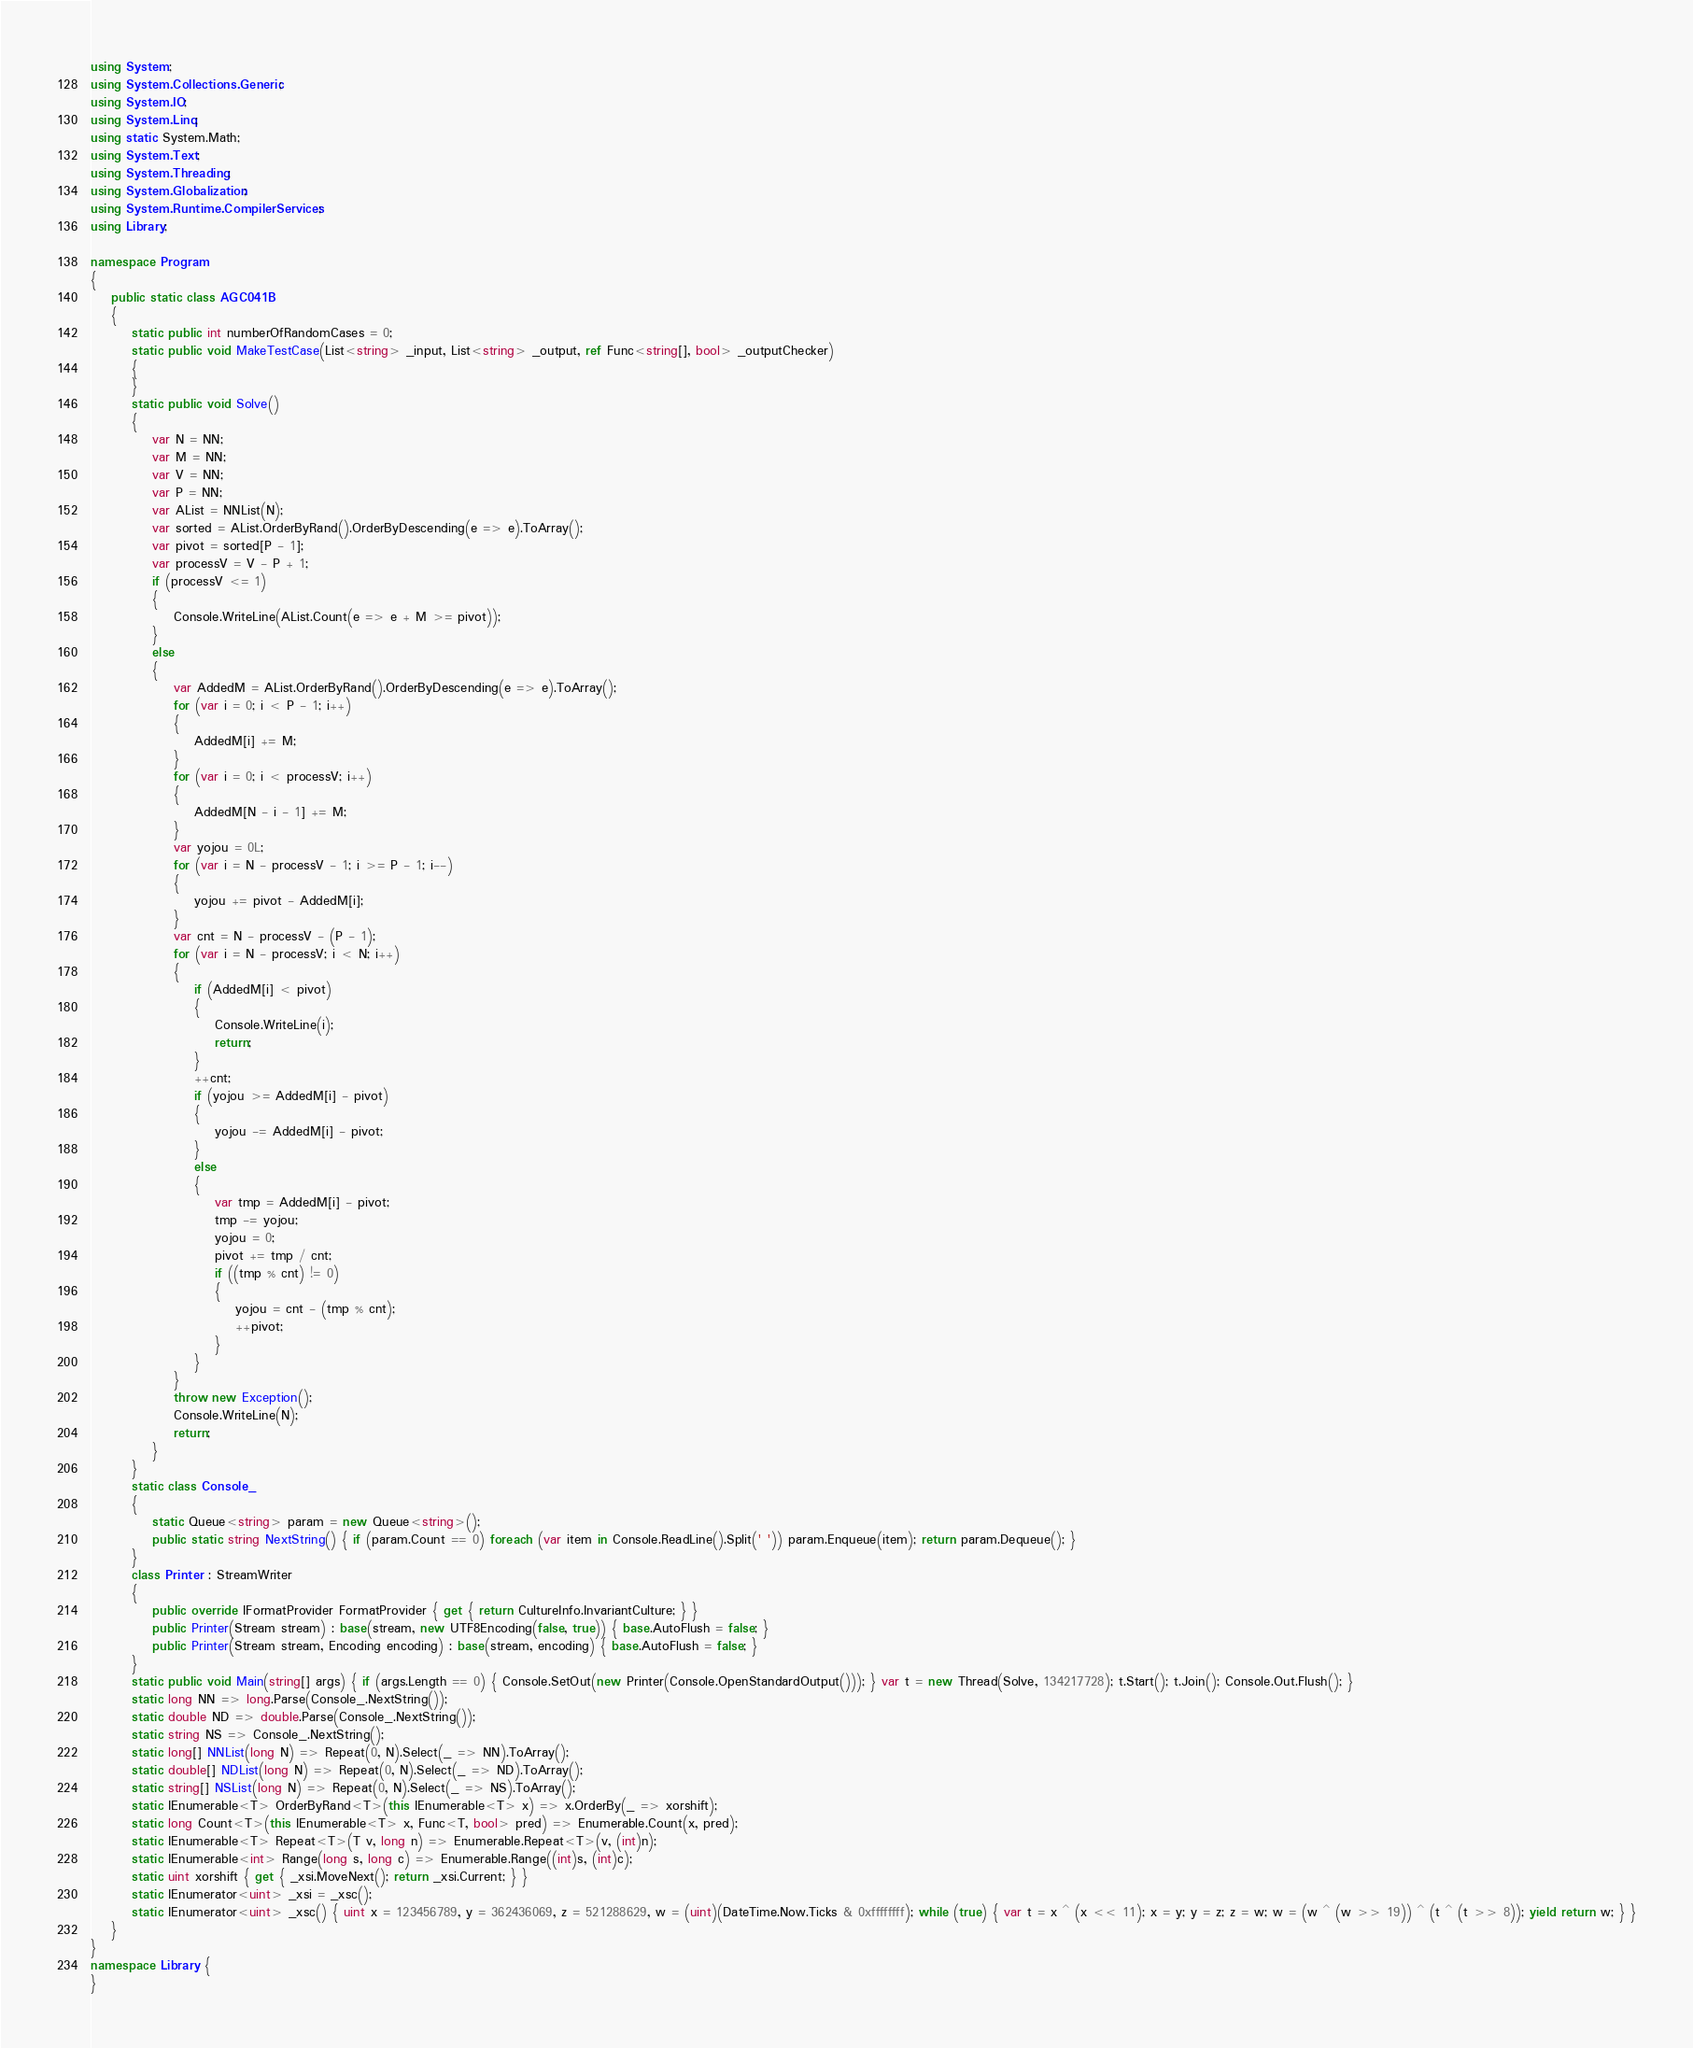<code> <loc_0><loc_0><loc_500><loc_500><_C#_>using System;
using System.Collections.Generic;
using System.IO;
using System.Linq;
using static System.Math;
using System.Text;
using System.Threading;
using System.Globalization;
using System.Runtime.CompilerServices;
using Library;

namespace Program
{
    public static class AGC041B
    {
        static public int numberOfRandomCases = 0;
        static public void MakeTestCase(List<string> _input, List<string> _output, ref Func<string[], bool> _outputChecker)
        {
        }
        static public void Solve()
        {
            var N = NN;
            var M = NN;
            var V = NN;
            var P = NN;
            var AList = NNList(N);
            var sorted = AList.OrderByRand().OrderByDescending(e => e).ToArray();
            var pivot = sorted[P - 1];
            var processV = V - P + 1;
            if (processV <= 1)
            {
                Console.WriteLine(AList.Count(e => e + M >= pivot));
            }
            else
            {
                var AddedM = AList.OrderByRand().OrderByDescending(e => e).ToArray();
                for (var i = 0; i < P - 1; i++)
                {
                    AddedM[i] += M;
                }
                for (var i = 0; i < processV; i++)
                {
                    AddedM[N - i - 1] += M;
                }
                var yojou = 0L;
                for (var i = N - processV - 1; i >= P - 1; i--)
                {
                    yojou += pivot - AddedM[i];
                }
                var cnt = N - processV - (P - 1);
                for (var i = N - processV; i < N; i++)
                {
                    if (AddedM[i] < pivot)
                    {
                        Console.WriteLine(i);
                        return;
                    }
                    ++cnt;
                    if (yojou >= AddedM[i] - pivot)
                    {
                        yojou -= AddedM[i] - pivot;
                    }
                    else
                    {
                        var tmp = AddedM[i] - pivot;
                        tmp -= yojou;
                        yojou = 0;
                        pivot += tmp / cnt;
                        if ((tmp % cnt) != 0)
                        {
                            yojou = cnt - (tmp % cnt);
                            ++pivot;
                        }
                    }
                }
                throw new Exception();
                Console.WriteLine(N);
                return;
            }
        }
        static class Console_
        {
            static Queue<string> param = new Queue<string>();
            public static string NextString() { if (param.Count == 0) foreach (var item in Console.ReadLine().Split(' ')) param.Enqueue(item); return param.Dequeue(); }
        }
        class Printer : StreamWriter
        {
            public override IFormatProvider FormatProvider { get { return CultureInfo.InvariantCulture; } }
            public Printer(Stream stream) : base(stream, new UTF8Encoding(false, true)) { base.AutoFlush = false; }
            public Printer(Stream stream, Encoding encoding) : base(stream, encoding) { base.AutoFlush = false; }
        }
        static public void Main(string[] args) { if (args.Length == 0) { Console.SetOut(new Printer(Console.OpenStandardOutput())); } var t = new Thread(Solve, 134217728); t.Start(); t.Join(); Console.Out.Flush(); }
        static long NN => long.Parse(Console_.NextString());
        static double ND => double.Parse(Console_.NextString());
        static string NS => Console_.NextString();
        static long[] NNList(long N) => Repeat(0, N).Select(_ => NN).ToArray();
        static double[] NDList(long N) => Repeat(0, N).Select(_ => ND).ToArray();
        static string[] NSList(long N) => Repeat(0, N).Select(_ => NS).ToArray();
        static IEnumerable<T> OrderByRand<T>(this IEnumerable<T> x) => x.OrderBy(_ => xorshift);
        static long Count<T>(this IEnumerable<T> x, Func<T, bool> pred) => Enumerable.Count(x, pred);
        static IEnumerable<T> Repeat<T>(T v, long n) => Enumerable.Repeat<T>(v, (int)n);
        static IEnumerable<int> Range(long s, long c) => Enumerable.Range((int)s, (int)c);
        static uint xorshift { get { _xsi.MoveNext(); return _xsi.Current; } }
        static IEnumerator<uint> _xsi = _xsc();
        static IEnumerator<uint> _xsc() { uint x = 123456789, y = 362436069, z = 521288629, w = (uint)(DateTime.Now.Ticks & 0xffffffff); while (true) { var t = x ^ (x << 11); x = y; y = z; z = w; w = (w ^ (w >> 19)) ^ (t ^ (t >> 8)); yield return w; } }
    }
}
namespace Library {
}
</code> 